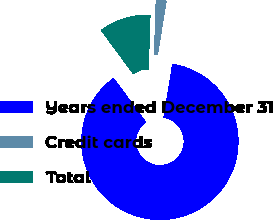Convert chart. <chart><loc_0><loc_0><loc_500><loc_500><pie_chart><fcel>Years ended December 31<fcel>Credit cards<fcel>Total<nl><fcel>87.32%<fcel>2.08%<fcel>10.6%<nl></chart> 